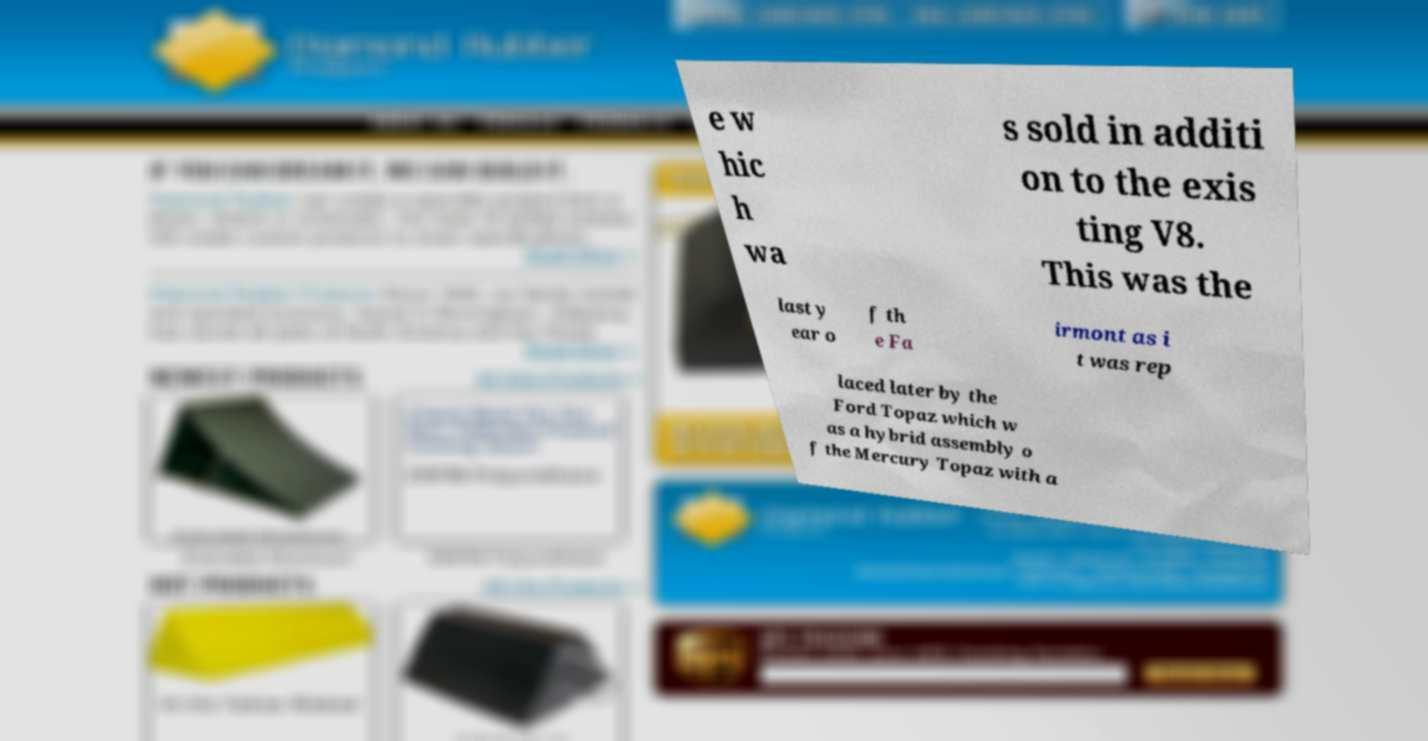Could you assist in decoding the text presented in this image and type it out clearly? e w hic h wa s sold in additi on to the exis ting V8. This was the last y ear o f th e Fa irmont as i t was rep laced later by the Ford Topaz which w as a hybrid assembly o f the Mercury Topaz with a 